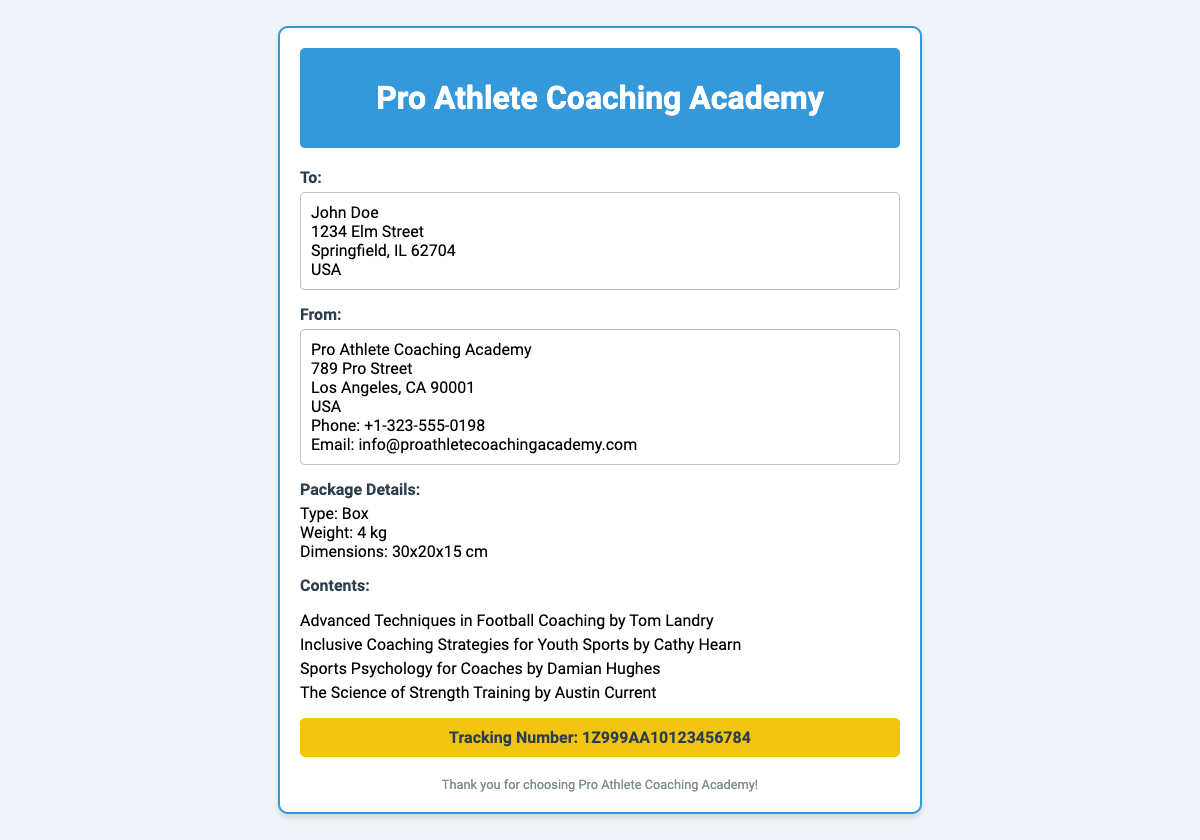What is the sender's email address? The sender's email address is stated in the document under the contact information.
Answer: info@proathletecoachingacademy.com What is the tracking number? The tracking number is prominently displayed in a dedicated section of the label.
Answer: 1Z999AA10123456784 What is the weight of the package? The weight of the package is mentioned in the packaging details section.
Answer: 4 kg Who is the recipient? The recipient's name is located in the "To" section of the shipping label.
Answer: John Doe What type of packaging is used? The type of packaging is specified in the package details section of the label.
Answer: Box How many educational sports books are in the package? The number of educational sports books is indicated by the list of contents provided.
Answer: 4 What is the address of the sender? The sender's address is outlined in the "From" section and includes the complete details.
Answer: 789 Pro Street, Los Angeles, CA 90001, USA What is the title of the first book listed? The title of the first book is presented in the contents section and is the first item listed.
Answer: Advanced Techniques in Football Coaching by Tom Landry 